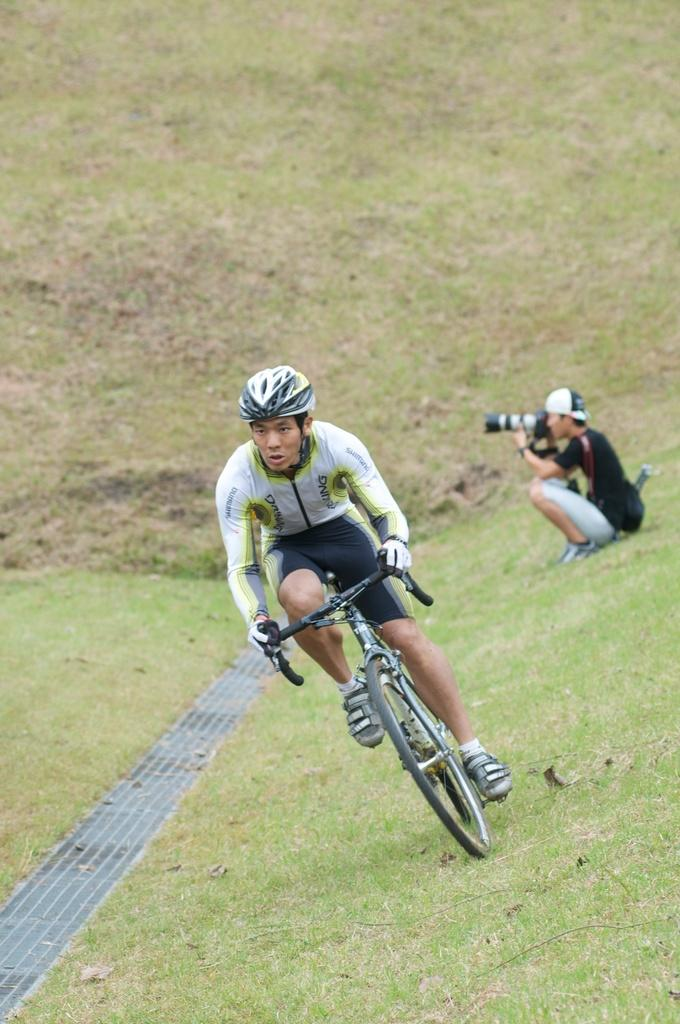How many people are in the image? There are two people in the image. What is one person doing in the image? One person is riding a bicycle on the grass. What is the other person holding in the image? The other person is holding a camera. Can you describe the clothing of the person holding the camera? The person holding the camera is wearing a cap. What type of insurance policy is the person riding the bicycle considering in the image? There is no mention of insurance in the image, so it cannot be determined if the person is considering any insurance policy. 